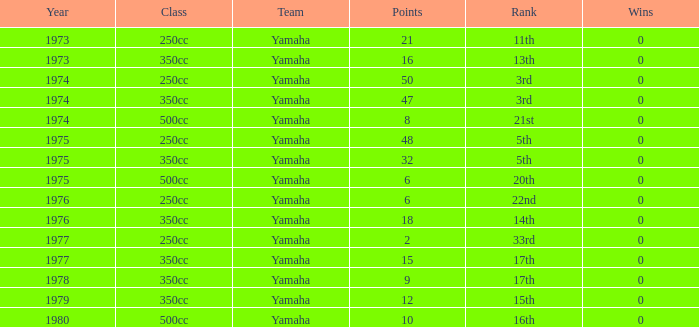Would you mind parsing the complete table? {'header': ['Year', 'Class', 'Team', 'Points', 'Rank', 'Wins'], 'rows': [['1973', '250cc', 'Yamaha', '21', '11th', '0'], ['1973', '350cc', 'Yamaha', '16', '13th', '0'], ['1974', '250cc', 'Yamaha', '50', '3rd', '0'], ['1974', '350cc', 'Yamaha', '47', '3rd', '0'], ['1974', '500cc', 'Yamaha', '8', '21st', '0'], ['1975', '250cc', 'Yamaha', '48', '5th', '0'], ['1975', '350cc', 'Yamaha', '32', '5th', '0'], ['1975', '500cc', 'Yamaha', '6', '20th', '0'], ['1976', '250cc', 'Yamaha', '6', '22nd', '0'], ['1976', '350cc', 'Yamaha', '18', '14th', '0'], ['1977', '250cc', 'Yamaha', '2', '33rd', '0'], ['1977', '350cc', 'Yamaha', '15', '17th', '0'], ['1978', '350cc', 'Yamaha', '9', '17th', '0'], ['1979', '350cc', 'Yamaha', '12', '15th', '0'], ['1980', '500cc', 'Yamaha', '10', '16th', '0']]} Which Points is the lowest one that has a Year larger than 1974, and a Rank of 15th? 12.0. 